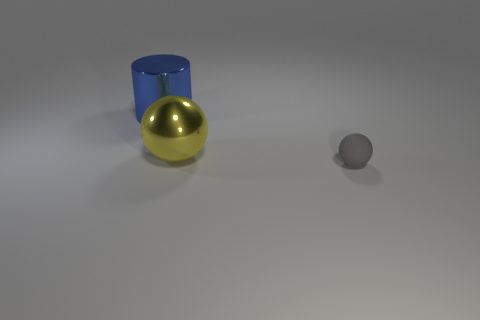There is a tiny rubber ball that is on the right side of the large metal object left of the metal ball; are there any big objects that are on the left side of it?
Provide a succinct answer. Yes. Are there any other things that have the same size as the rubber sphere?
Provide a succinct answer. No. What is the color of the sphere to the right of the big object that is in front of the blue object?
Your response must be concise. Gray. What number of small things are either metallic cylinders or red spheres?
Your answer should be compact. 0. What is the color of the object that is both left of the gray rubber sphere and in front of the blue metallic object?
Provide a short and direct response. Yellow. Is the material of the large blue thing the same as the big ball?
Provide a short and direct response. Yes. The blue shiny thing is what shape?
Your answer should be compact. Cylinder. How many small gray things are in front of the big thing on the left side of the sphere behind the gray object?
Your answer should be compact. 1. There is another object that is the same shape as the big yellow metallic object; what color is it?
Offer a terse response. Gray. What shape is the big shiny object that is right of the large object behind the ball behind the gray matte sphere?
Keep it short and to the point. Sphere. 